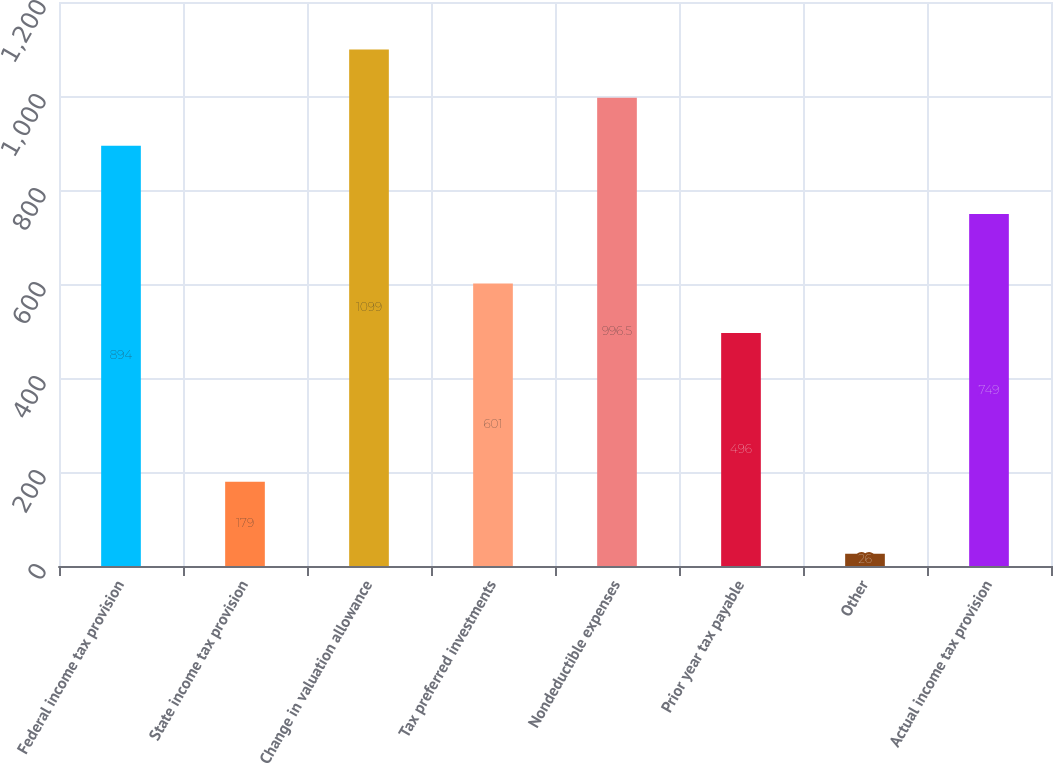<chart> <loc_0><loc_0><loc_500><loc_500><bar_chart><fcel>Federal income tax provision<fcel>State income tax provision<fcel>Change in valuation allowance<fcel>Tax preferred investments<fcel>Nondeductible expenses<fcel>Prior year tax payable<fcel>Other<fcel>Actual income tax provision<nl><fcel>894<fcel>179<fcel>1099<fcel>601<fcel>996.5<fcel>496<fcel>26<fcel>749<nl></chart> 